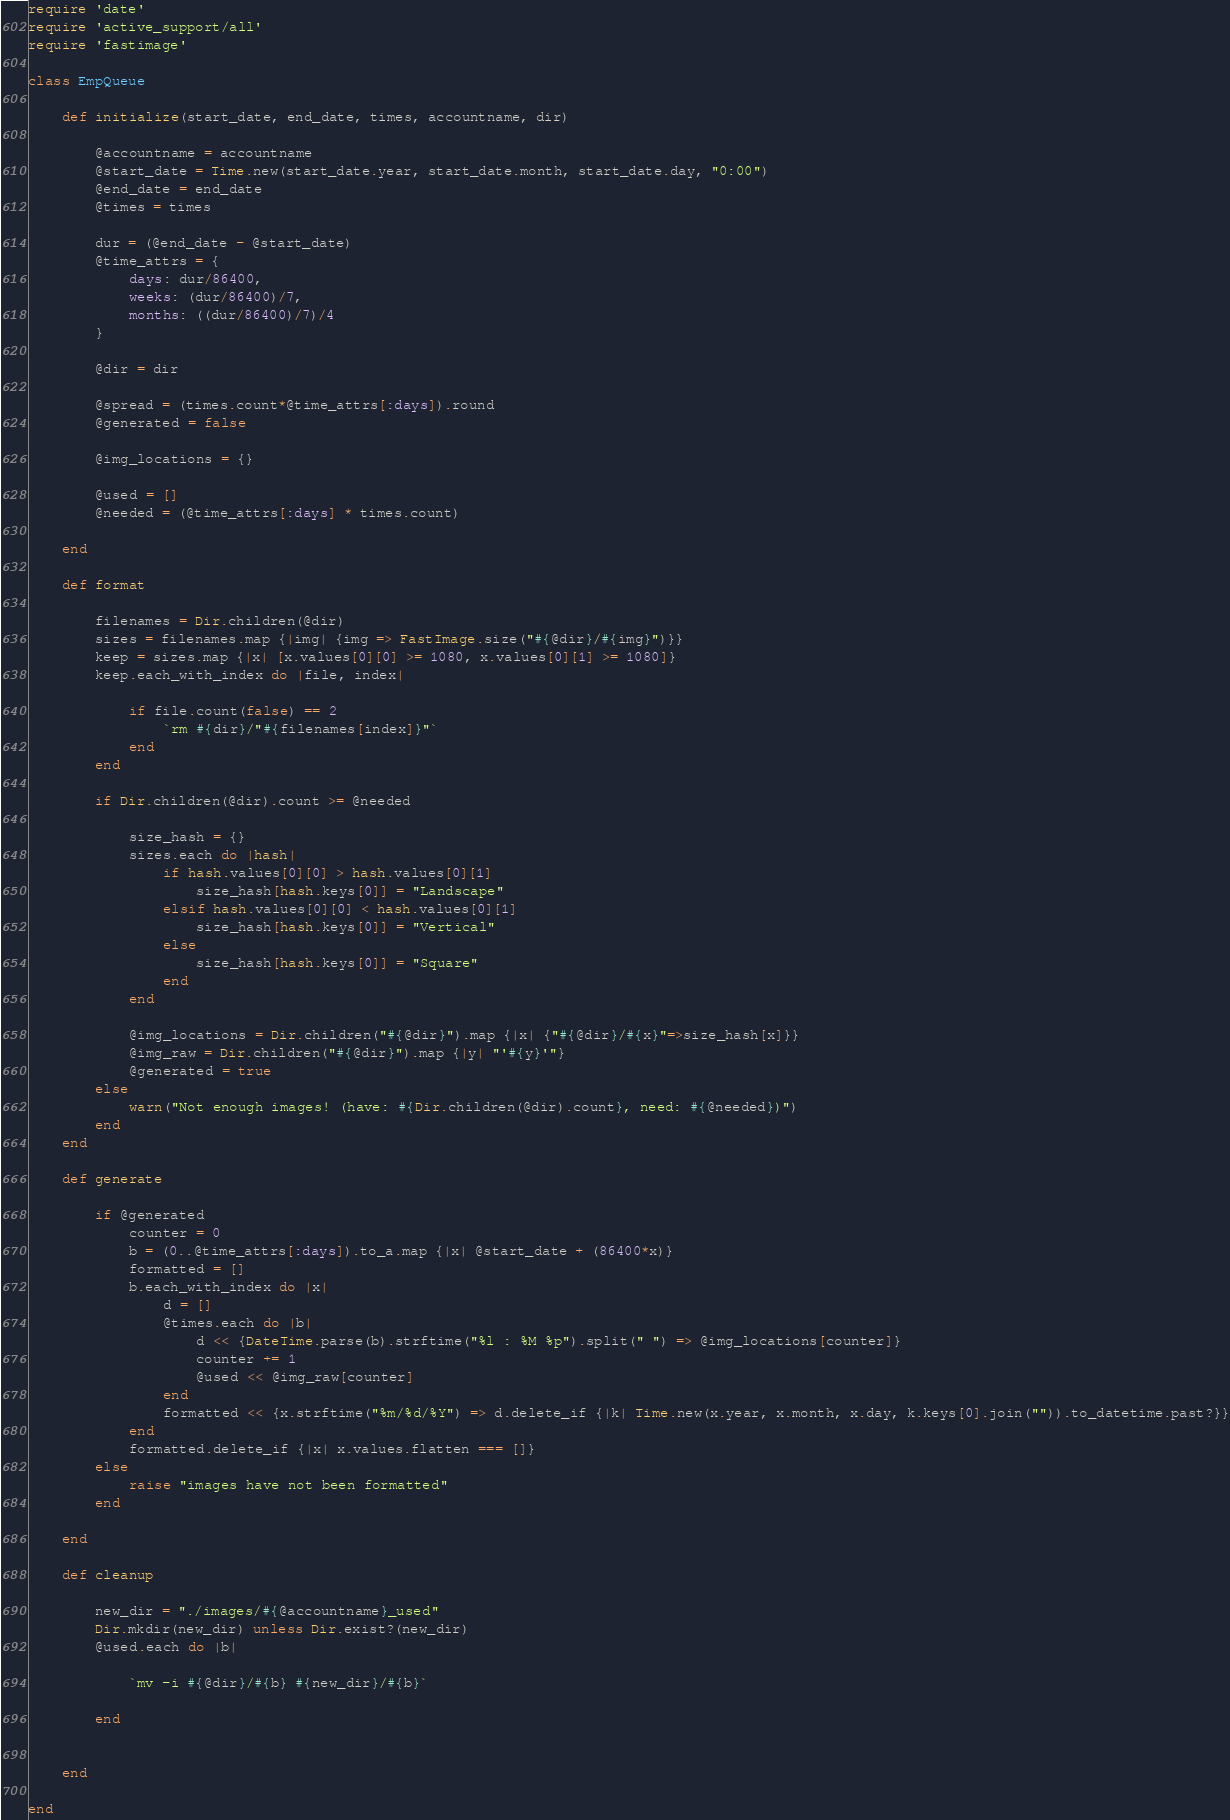Convert code to text. <code><loc_0><loc_0><loc_500><loc_500><_Ruby_>require 'date'
require 'active_support/all'
require 'fastimage'

class EmpQueue

    def initialize(start_date, end_date, times, accountname, dir)

        @accountname = accountname
        @start_date = Time.new(start_date.year, start_date.month, start_date.day, "0:00")
        @end_date = end_date
        @times = times

        dur = (@end_date - @start_date)
        @time_attrs = {
            days: dur/86400,
            weeks: (dur/86400)/7,
            months: ((dur/86400)/7)/4
        }

        @dir = dir

        @spread = (times.count*@time_attrs[:days]).round
        @generated = false

        @img_locations = {}

        @used = []
        @needed = (@time_attrs[:days] * times.count) 

    end

    def format

        filenames = Dir.children(@dir)
        sizes = filenames.map {|img| {img => FastImage.size("#{@dir}/#{img}")}}
        keep = sizes.map {|x| [x.values[0][0] >= 1080, x.values[0][1] >= 1080]}
        keep.each_with_index do |file, index|

            if file.count(false) == 2
                `rm #{dir}/"#{filenames[index]}"`
            end
        end

        if Dir.children(@dir).count >= @needed

            size_hash = {}
            sizes.each do |hash|
                if hash.values[0][0] > hash.values[0][1]
                    size_hash[hash.keys[0]] = "Landscape"
                elsif hash.values[0][0] < hash.values[0][1]
                    size_hash[hash.keys[0]] = "Vertical"
                else
                    size_hash[hash.keys[0]] = "Square"
                end
            end

            @img_locations = Dir.children("#{@dir}").map {|x| {"#{@dir}/#{x}"=>size_hash[x]}}
            @img_raw = Dir.children("#{@dir}").map {|y| "'#{y}'"}
            @generated = true
        else
            warn("Not enough images! (have: #{Dir.children(@dir).count}, need: #{@needed})")
        end
    end

    def generate 

        if @generated
            counter = 0
            b = (0..@time_attrs[:days]).to_a.map {|x| @start_date + (86400*x)}
            formatted = []
            b.each_with_index do |x|
                d = [] 
                @times.each do |b| 
                    d << {DateTime.parse(b).strftime("%l : %M %p").split(" ") => @img_locations[counter]}
                    counter += 1
                    @used << @img_raw[counter] 
                end
                formatted << {x.strftime("%m/%d/%Y") => d.delete_if {|k| Time.new(x.year, x.month, x.day, k.keys[0].join("")).to_datetime.past?}}
            end
            formatted.delete_if {|x| x.values.flatten === []}
        else
            raise "images have not been formatted"
        end

    end

    def cleanup

        new_dir = "./images/#{@accountname}_used"
        Dir.mkdir(new_dir) unless Dir.exist?(new_dir)
        @used.each do |b| 

            `mv -i #{@dir}/#{b} #{new_dir}/#{b}`

        end
        

    end

end
</code> 